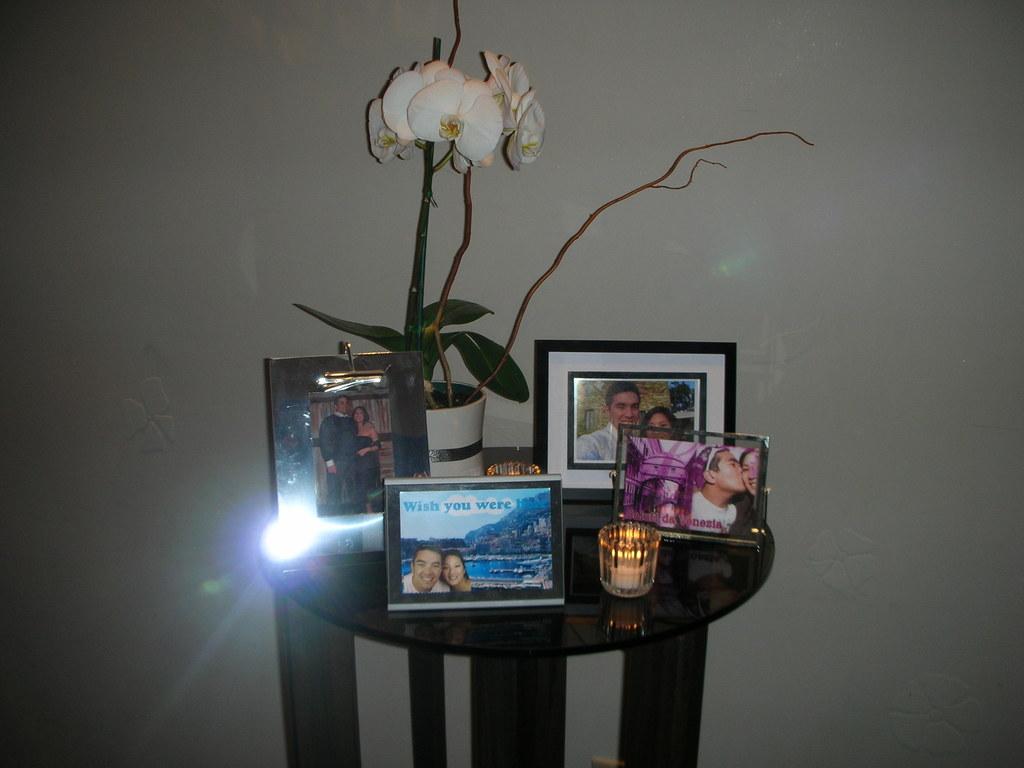The picture says it wishes what?
Provide a succinct answer. You were here. Do all the photographs have people in them?
Your response must be concise. Answering does not require reading text in the image. 